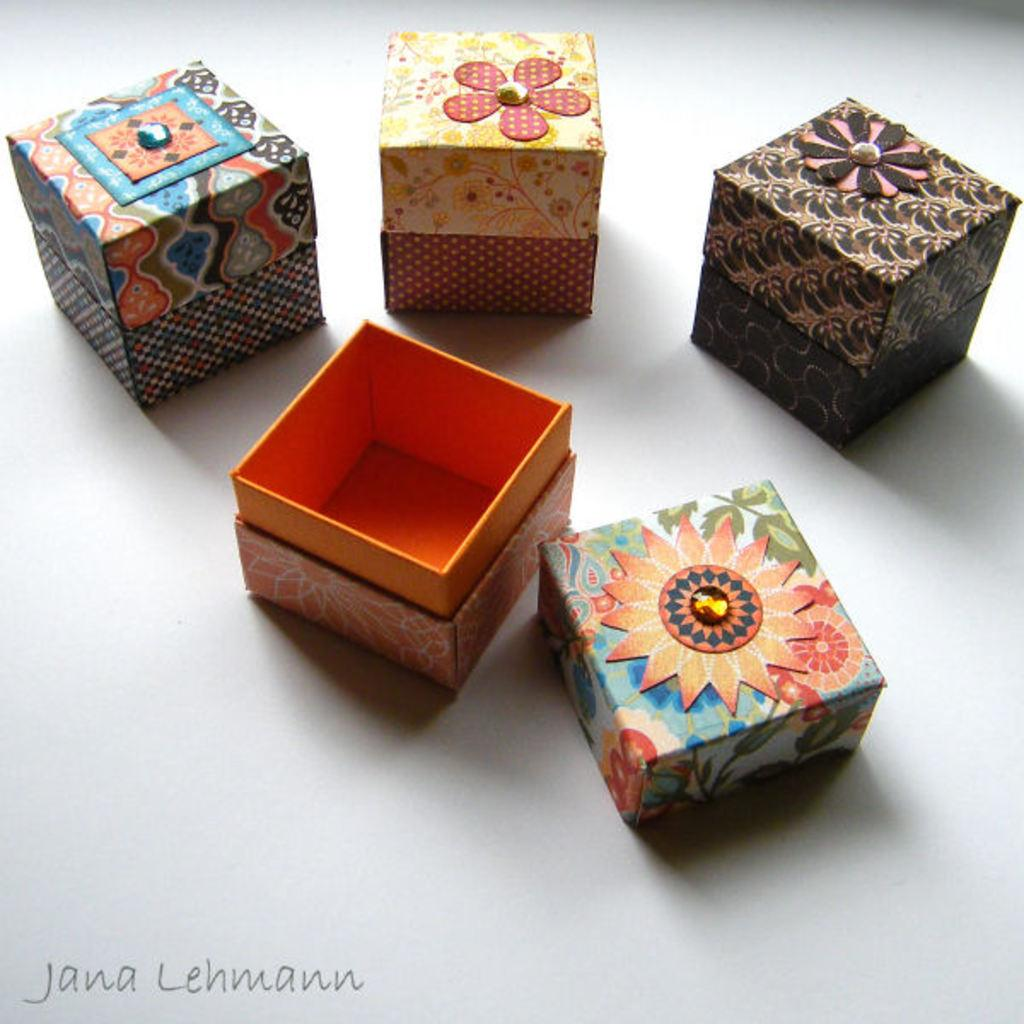Provide a one-sentence caption for the provided image. Jana Lehmann is the photographer for those boxes. 